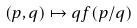Convert formula to latex. <formula><loc_0><loc_0><loc_500><loc_500>( p , q ) \mapsto q f ( p / q )</formula> 